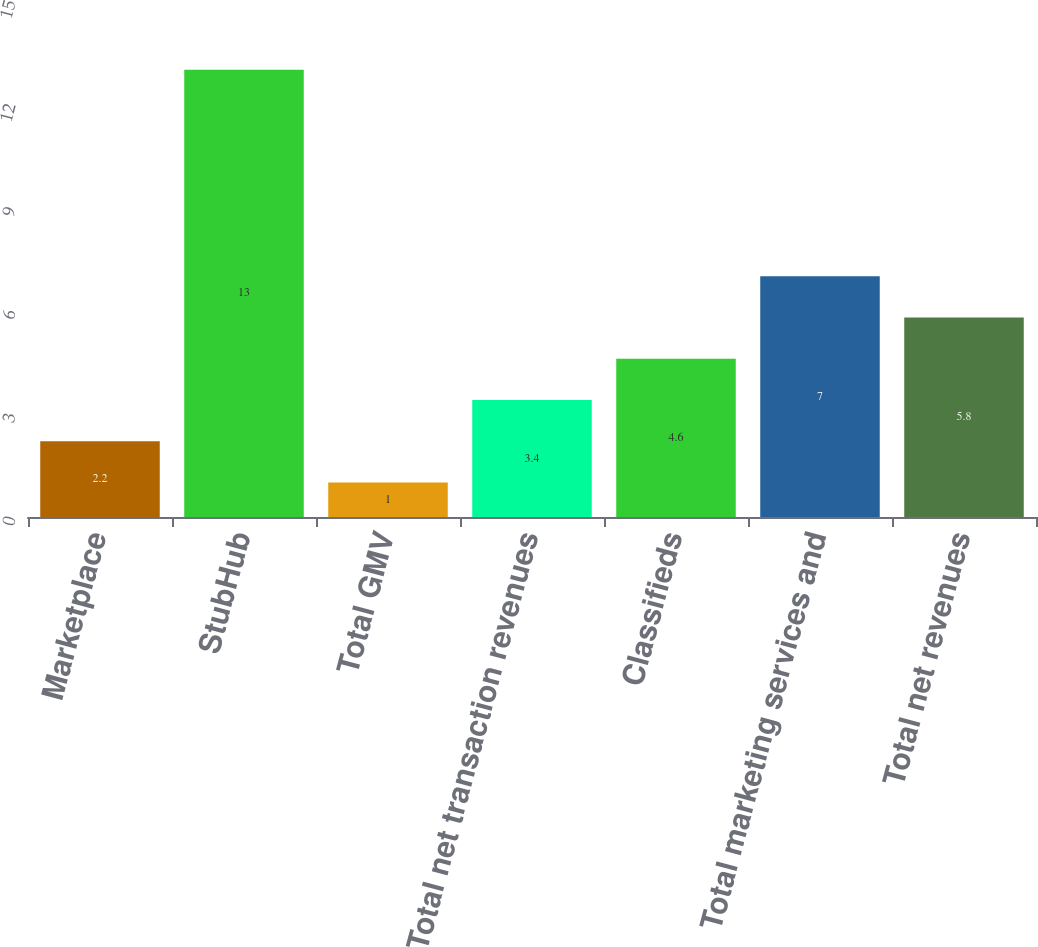Convert chart. <chart><loc_0><loc_0><loc_500><loc_500><bar_chart><fcel>Marketplace<fcel>StubHub<fcel>Total GMV<fcel>Total net transaction revenues<fcel>Classifieds<fcel>Total marketing services and<fcel>Total net revenues<nl><fcel>2.2<fcel>13<fcel>1<fcel>3.4<fcel>4.6<fcel>7<fcel>5.8<nl></chart> 